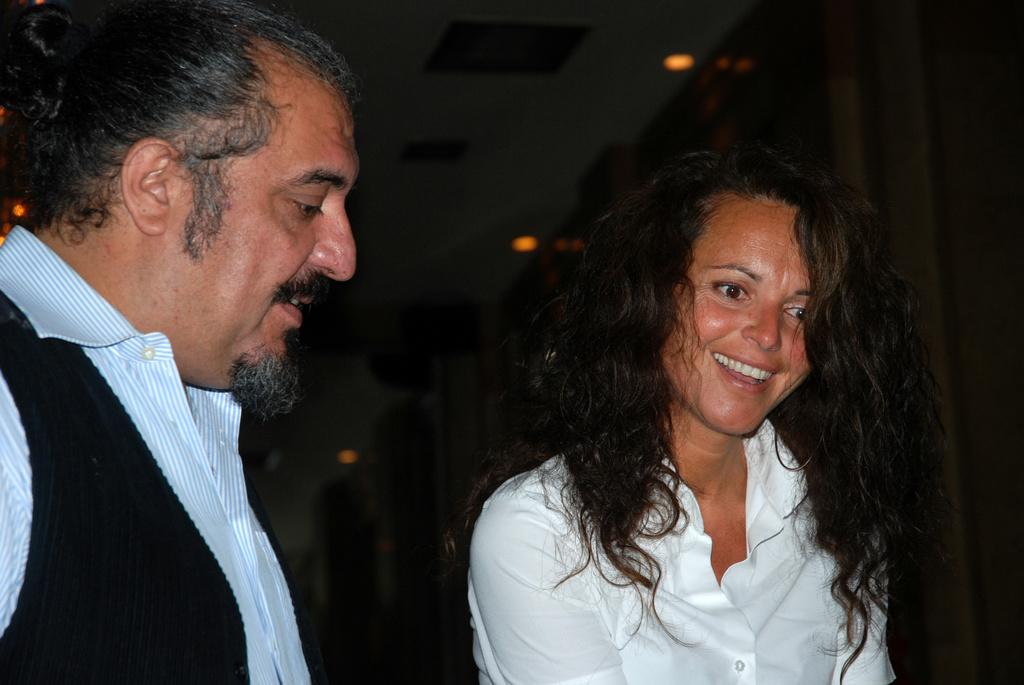How many people are in the image? There are two people in the image. What is the expression of one of the people in the image? One person is smiling. What can be seen in the background of the image? There are lights visible in the background of the image. How much money is the person holding in the image? There is no indication of money or any object being held by a person in the image. 